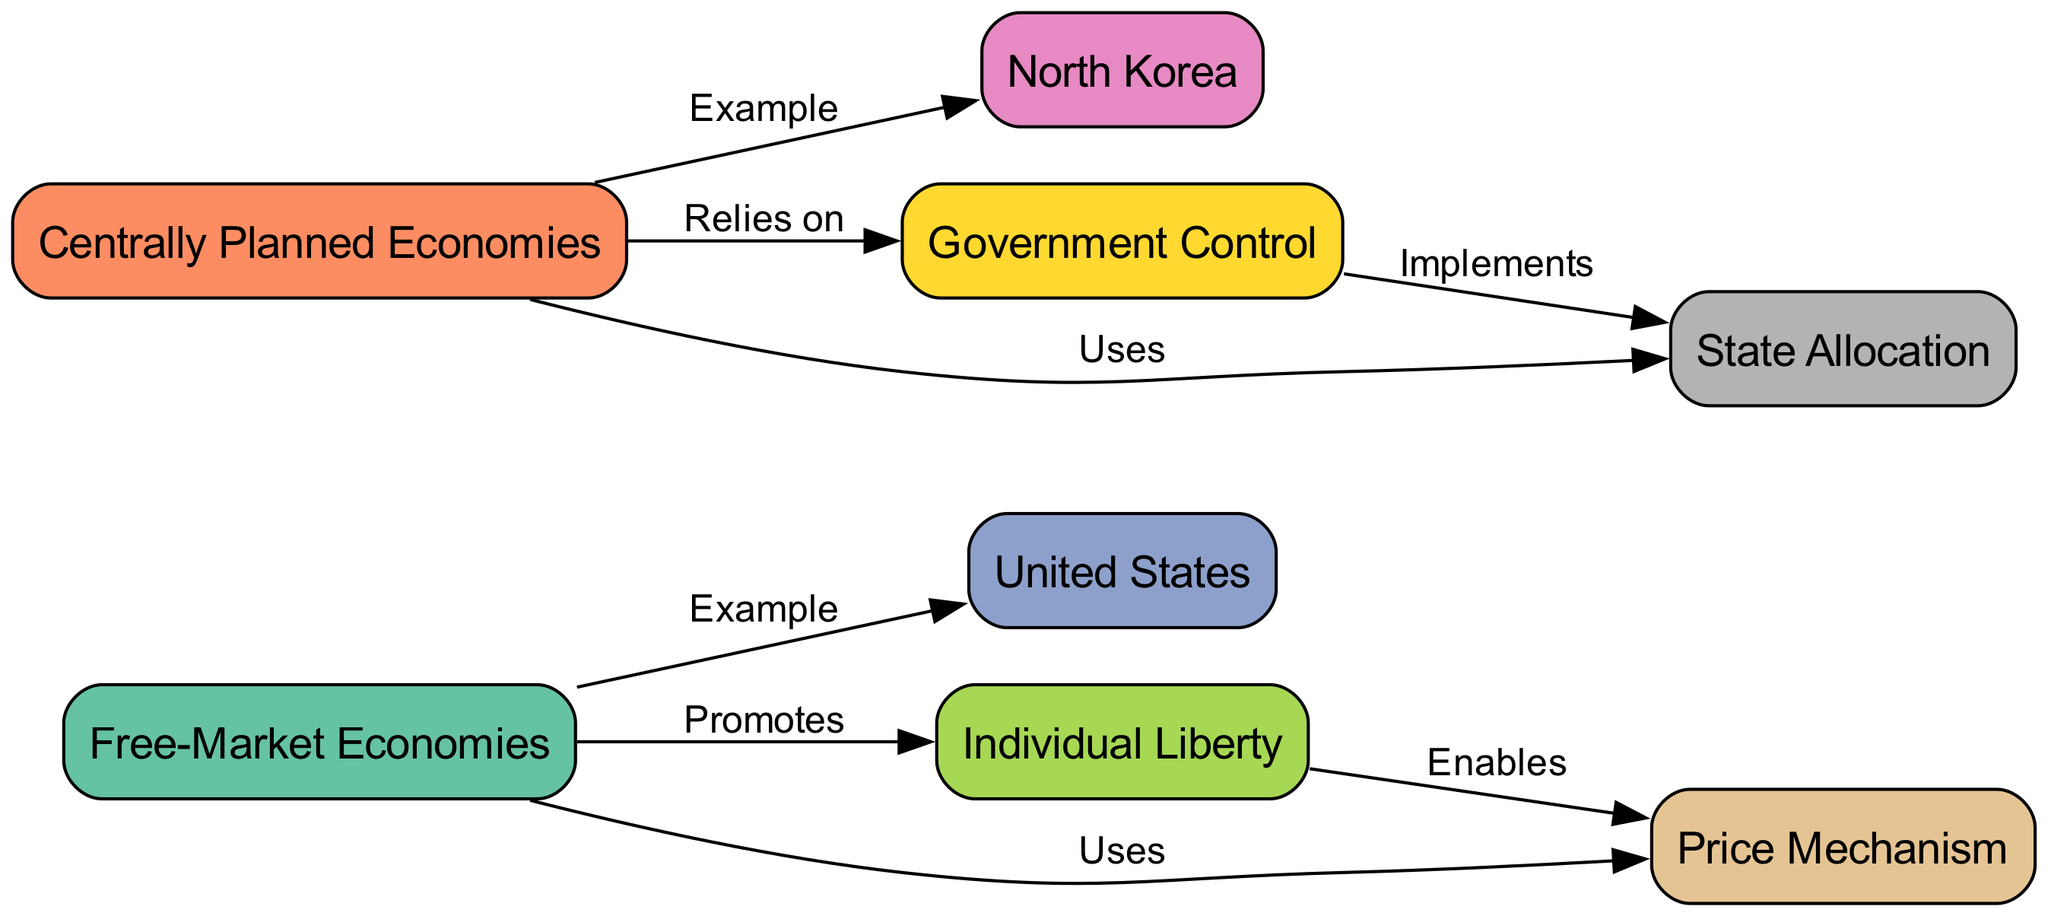What are the two main types of economies represented in the diagram? The diagram has two main nodes representing the types of economies: "Free-Market Economies" and "Centrally Planned Economies." These nodes are centrally placed and highlight the comparative focus of the diagram.
Answer: Free-Market Economies, Centrally Planned Economies Which country is used as an example of a Free-Market Economy? The diagram features an edge labeled "Example" that connects "Free-Market Economies" to "United States," indicating that the United States is represented as a case of a free-market economy.
Answer: United States How does Free-Market Economies promote Individual Liberty? The diagram shows an arrow from "Free-Market Economies" to "Individual Liberty" labeled "Promotes." This indicates the relationship where free-market economies are believed to encourage or enhance individual freedom.
Answer: Promotes What does Centrally Planned Economies rely on? There is a connection labeled "Relies on" from "Centrally Planned Economies" to "Government Control." This indicates that centrally planned economies fundamentally depend on strong government oversight and regulation.
Answer: Government Control How many total nodes are in the diagram? The diagram highlights eight distinct nodes, each representing a different concept related to economies. By counting each node visually or referencing the list, we confirm this total.
Answer: 8 Which concept does the Price Mechanism enable according to the diagram? The diagram shows "Individual Liberty" connecting to "Price Mechanism" with an edge labeled "Enables." This relationship suggests that the functioning of price mechanisms in a free market supports individual freedom.
Answer: Individual Liberty What is the connection between Government Control and State Allocation? The diagram illustrates an arrow labeled "Implements" from "Government Control" to "State Allocation," indicating that government control usually manifests through the allocation of resources by the state in a centrally planned economy.
Answer: Implements What is the total number of edges in the diagram? By counting the lines that connect different nodes (the edges), we find that there are a total of eight edges indicating the relationships between the various concepts represented.
Answer: 8 Which example is associated with Centrally Planned Economies? The diagram illustrates an "Example" labeled edge from "Centrally Planned Economies" to "North Korea," clearly identifying North Korea as the example used for this type of economy.
Answer: North Korea 